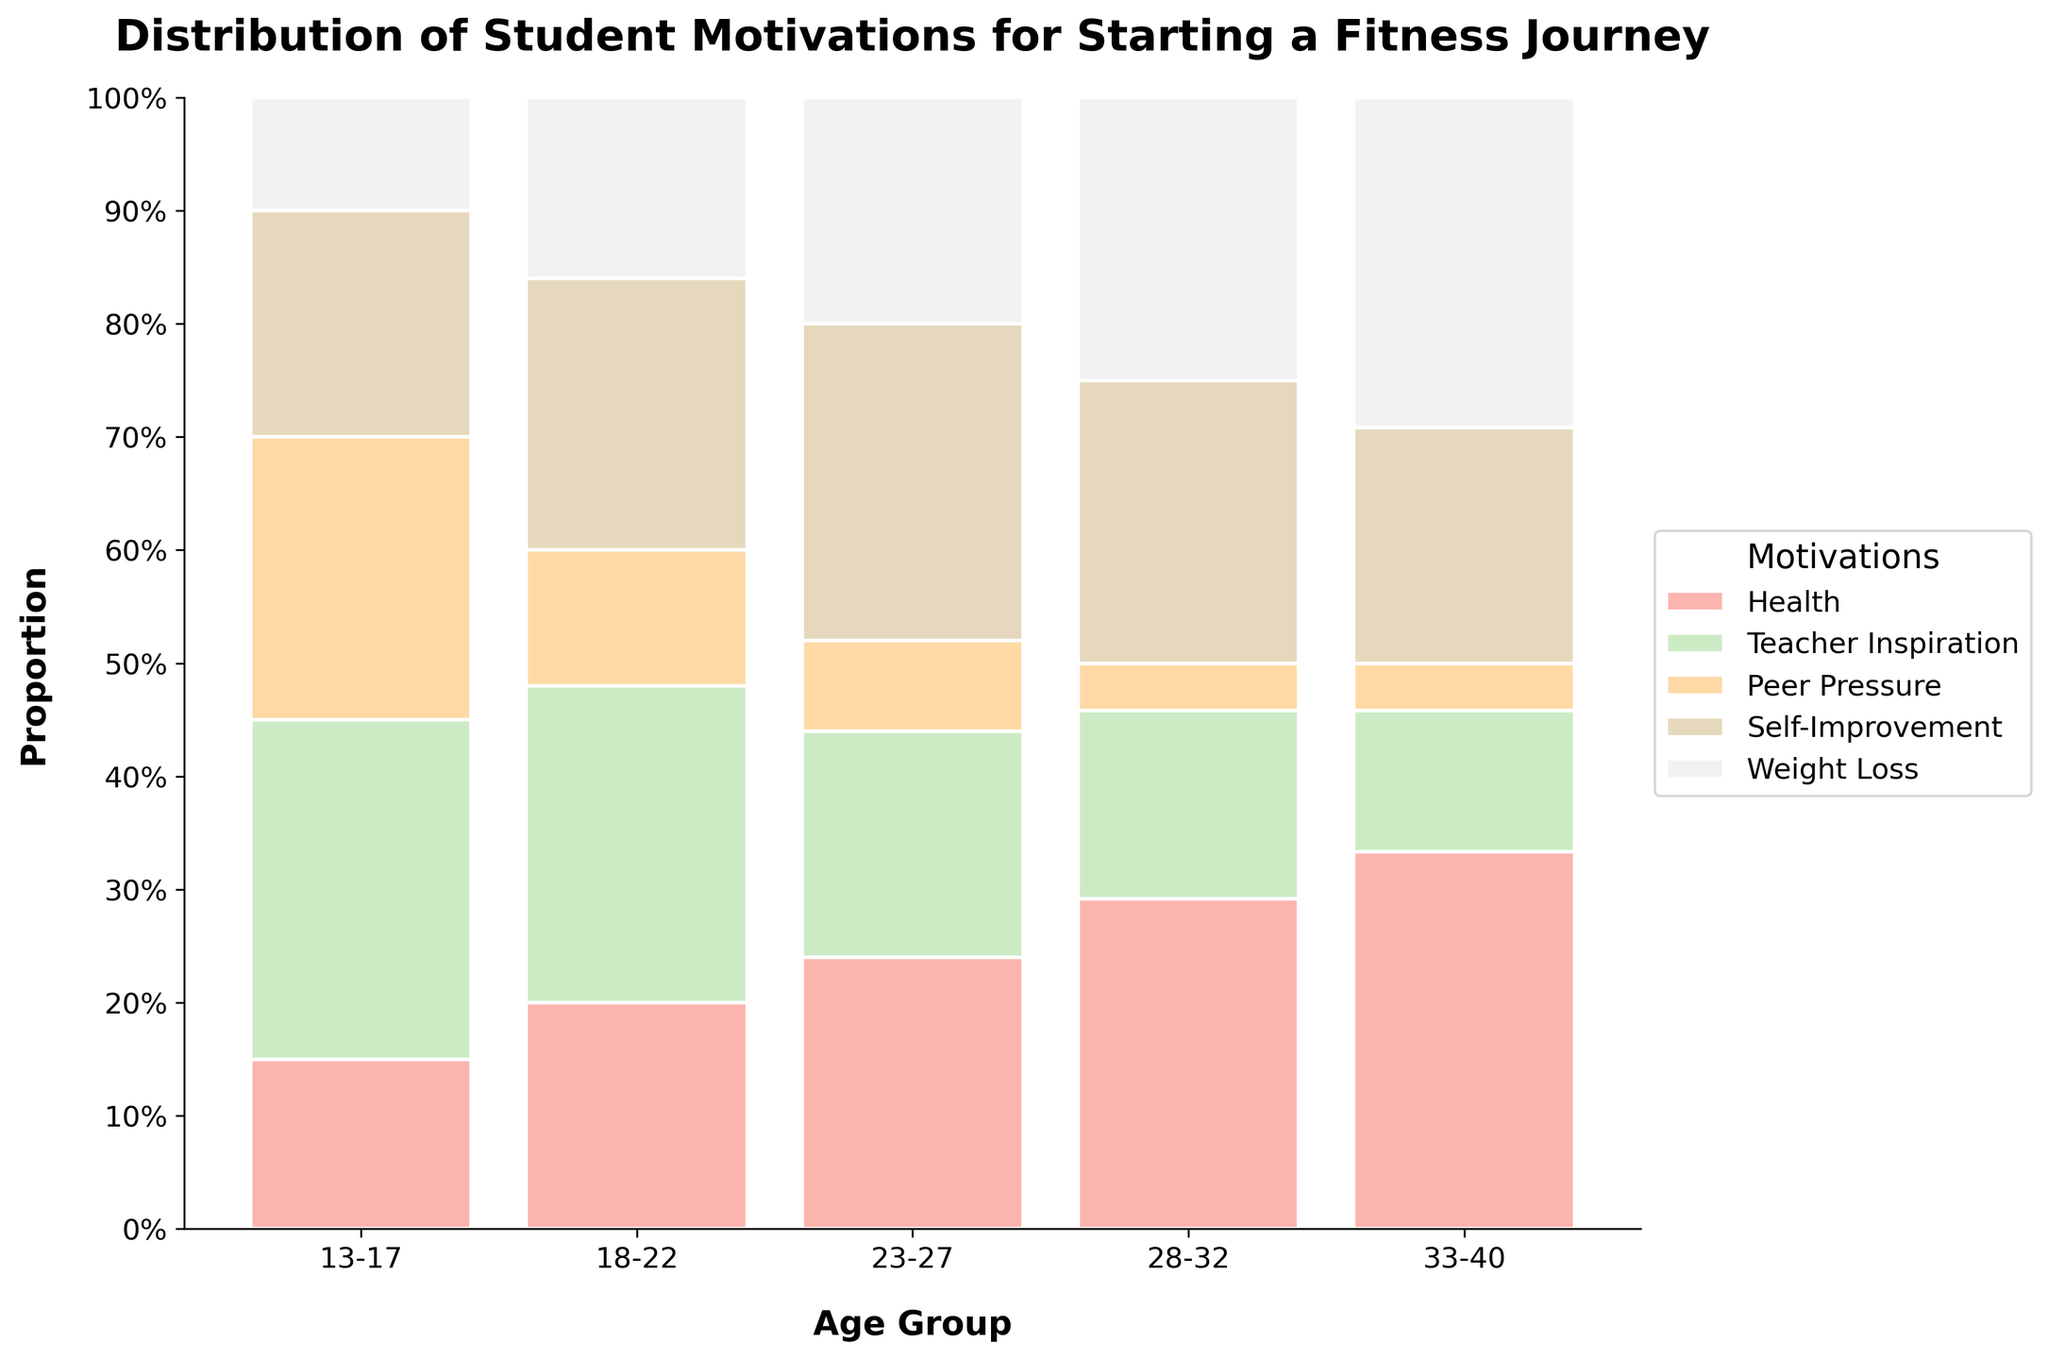What is the title of the mosaic plot? The title is typically displayed at the top of the plot. In this case, it would read "Distribution of Student Motivations for Starting a Fitness Journey".
Answer: Distribution of Student Motivations for Starting a Fitness Journey What is the most common motivation for starting a fitness journey for age group 33-40? Observing the highest proportion in the segment for age group 33-40, it is for "Health".
Answer: Health Which age group has the largest proportion of students motivated by "Teacher Inspiration"? Check the tallest segment within each age group labeled "Teacher Inspiration". The tallest segment appears in age group 18-22.
Answer: 18-22 How does the proportion of "Weight Loss" motivations change across age groups from 13-17 to 33-40? Examine the segments for "Weight Loss" across each age group. They increase gradually in size from 13-17 (smallest) to 33-40 (largest).
Answer: Increases Which motivation decreases noticeably as age groups increase from 13-17 to 33-40? Observe the segments for each motivation. "Peer Pressure" visibly decreases in size from age group 13-17 to age group 33-40.
Answer: Peer Pressure In which age group is "Self-Improvement" the most frequent motivation for starting a fitness journey? Look for the tallest segment under "Self-Improvement" across age groups. It is the tallest in the age group 23-27.
Answer: 23-27 Compare the proportion of motivations "Health" and "Weight Loss" for age group 28-32. Which is more common? Observe the height of the segments for both "Health" and "Weight Loss" in age group 28-32. "Weight Loss" is larger than "Health".
Answer: Weight Loss What is the combined proportion of "Teacher Inspiration" and "Self-Improvement" for age group 18-22? Add the proportions of "Teacher Inspiration" and "Self-Improvement" as per the mosaic plot for age group 18-22.
Answer: 0.35 + 0.30 = 0.65 What is the least common motivation for students in age group 23-27? Observe the smallest segment within the age group 23-27. It corresponds to "Peer Pressure".
Answer: Peer Pressure 